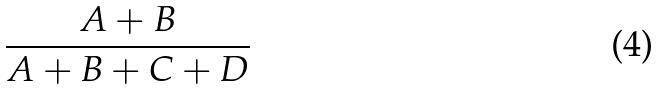Convert formula to latex. <formula><loc_0><loc_0><loc_500><loc_500>\frac { A + B } { A + B + C + D }</formula> 